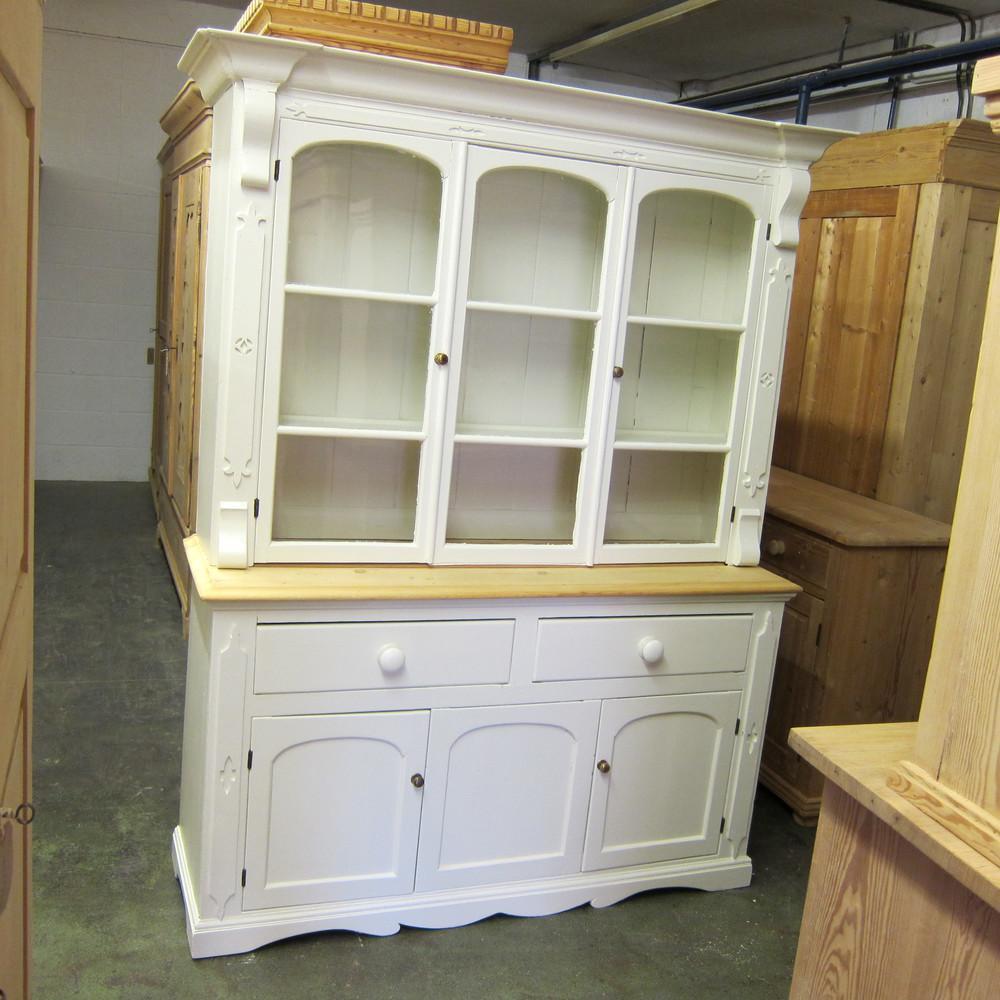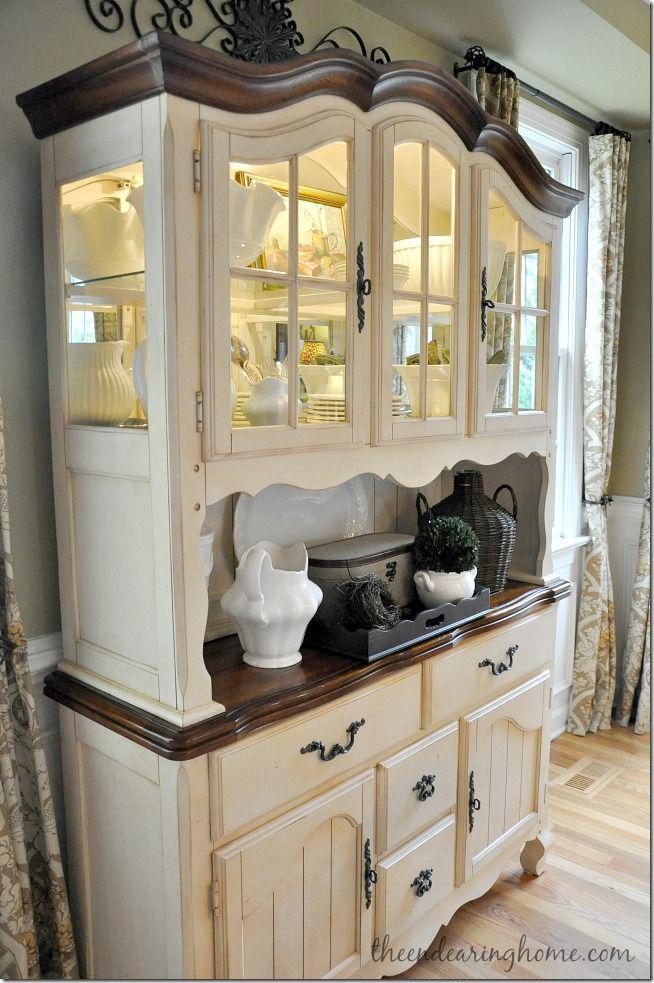The first image is the image on the left, the second image is the image on the right. Examine the images to the left and right. Is the description "The right image contains a turquoise wooden cabinet." accurate? Answer yes or no. No. The first image is the image on the left, the second image is the image on the right. For the images displayed, is the sentence "Both cabinets are filled with crockery." factually correct? Answer yes or no. No. 